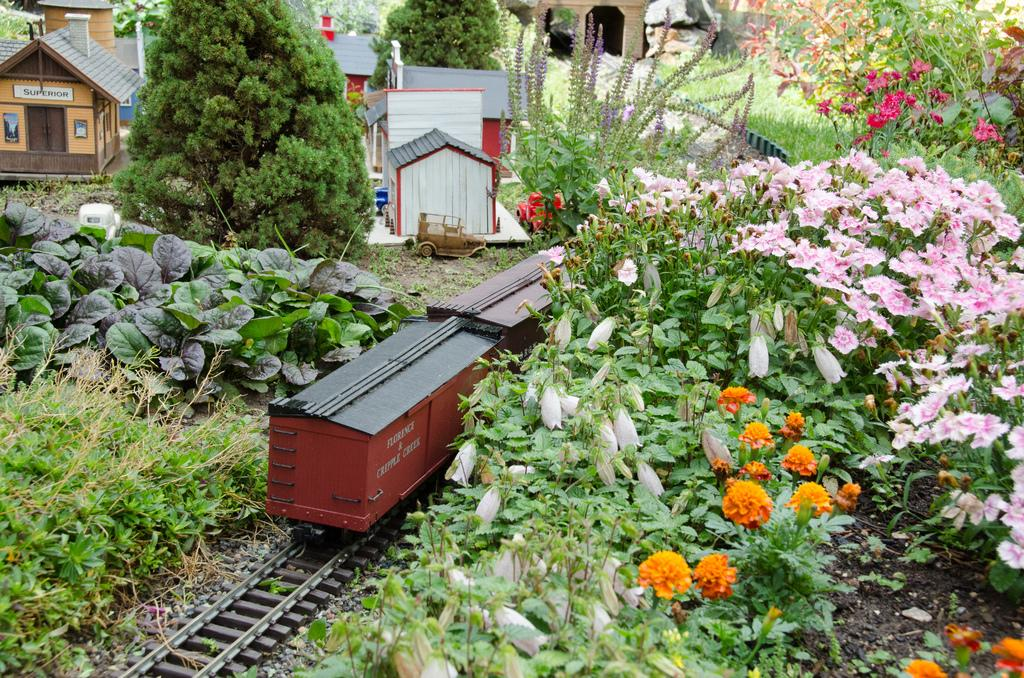What is the main subject of the image? The main subject of the image is a toy goods train on a railway track. What can be seen near the railway track? There are plants with flowers near the railway track. What other toy objects are present in the image? There are toy houses in the image. What type of ground is visible in the image? Grass is present on the ground in the image. How does the fly interact with the toy goods train in the image? There is no fly present in the image, so it cannot interact with the toy goods train. 